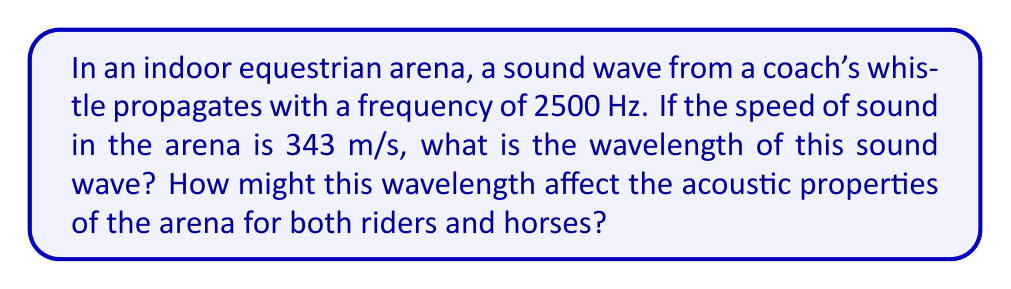Teach me how to tackle this problem. To solve this problem, we'll use the wave equation that relates wave speed, frequency, and wavelength:

$$v = f \lambda$$

Where:
$v$ = wave speed (m/s)
$f$ = frequency (Hz)
$\lambda$ = wavelength (m)

Given:
$v = 343$ m/s
$f = 2500$ Hz

Step 1: Rearrange the equation to solve for wavelength:
$$\lambda = \frac{v}{f}$$

Step 2: Substitute the known values:
$$\lambda = \frac{343 \text{ m/s}}{2500 \text{ Hz}}$$

Step 3: Calculate the wavelength:
$$\lambda = 0.1372 \text{ m}$$

The wavelength of the sound wave is approximately 0.1372 meters or 13.72 cm.

Impact on acoustic properties:
1. Reflection: Wavelengths of this size (13.72 cm) are likely to reflect off many surfaces in the arena, including walls, floors, and obstacles. This can create echoes and reverberation.

2. Diffraction: The wavelength is small enough to diffract around larger objects like horses and riders, but may be partially blocked by smaller arena features.

3. Interference: Multiple reflections can lead to constructive and destructive interference, creating areas of amplified or reduced sound intensity.

4. Perception: Humans and horses have different hearing ranges. This frequency (2500 Hz) is well within human hearing range but may be perceived differently by horses, potentially affecting their behavior.

5. Arena design: Understanding this wavelength can inform acoustic treatments and arena design to optimize communication between coaches, riders, and horses while minimizing disruptive echoes or reverberations.
Answer: $\lambda = 0.1372 \text{ m}$ 